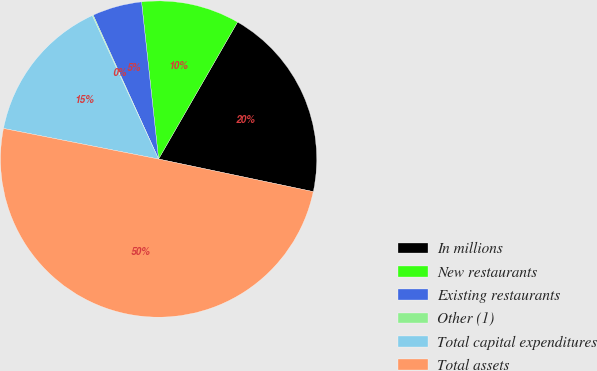Convert chart. <chart><loc_0><loc_0><loc_500><loc_500><pie_chart><fcel>In millions<fcel>New restaurants<fcel>Existing restaurants<fcel>Other (1)<fcel>Total capital expenditures<fcel>Total assets<nl><fcel>19.98%<fcel>10.04%<fcel>5.07%<fcel>0.1%<fcel>15.01%<fcel>49.79%<nl></chart> 